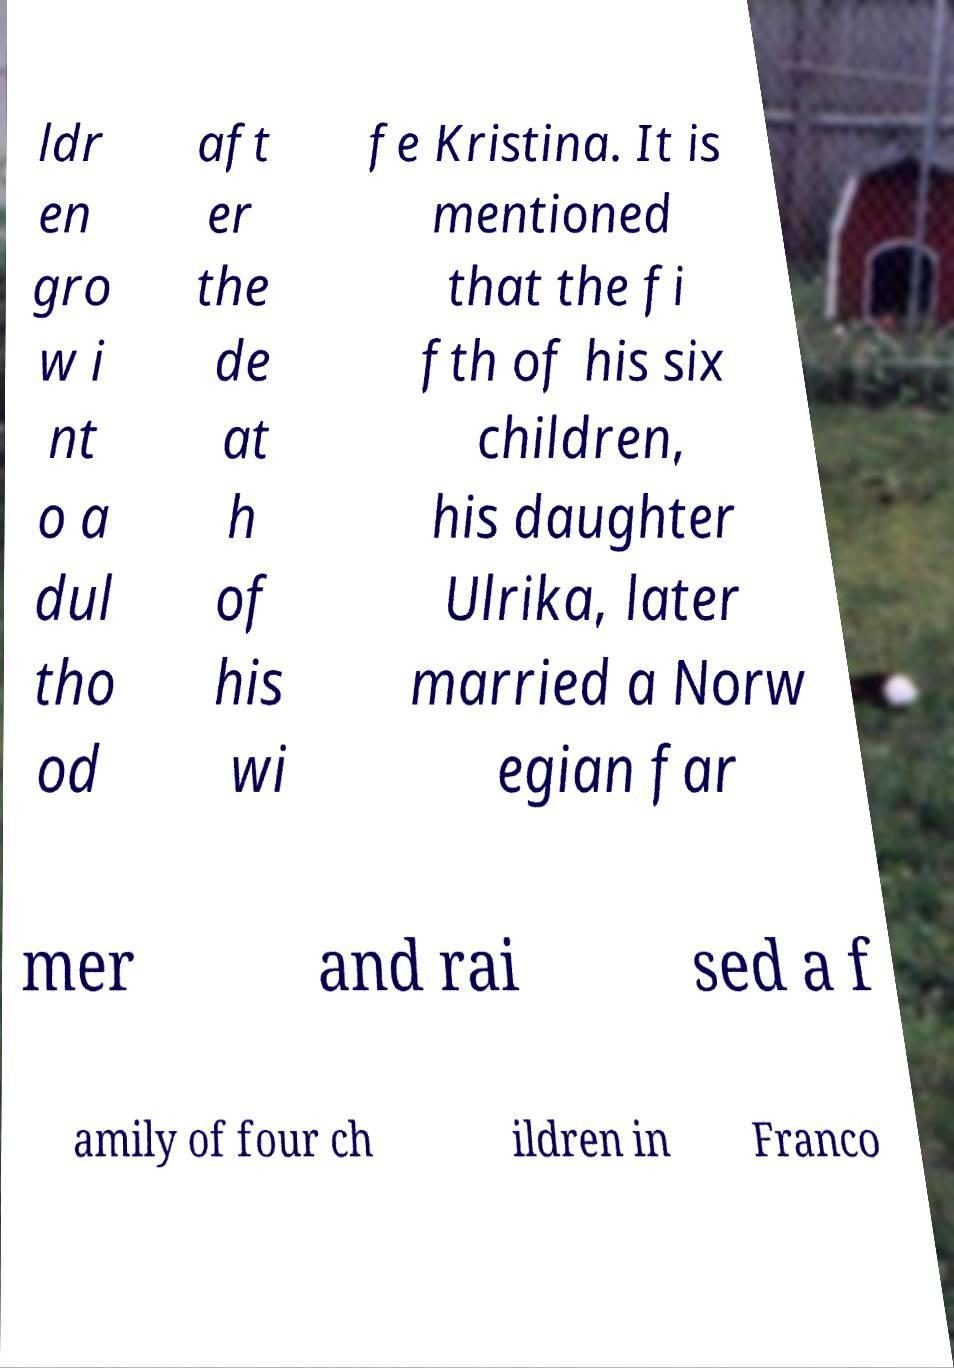There's text embedded in this image that I need extracted. Can you transcribe it verbatim? ldr en gro w i nt o a dul tho od aft er the de at h of his wi fe Kristina. It is mentioned that the fi fth of his six children, his daughter Ulrika, later married a Norw egian far mer and rai sed a f amily of four ch ildren in Franco 